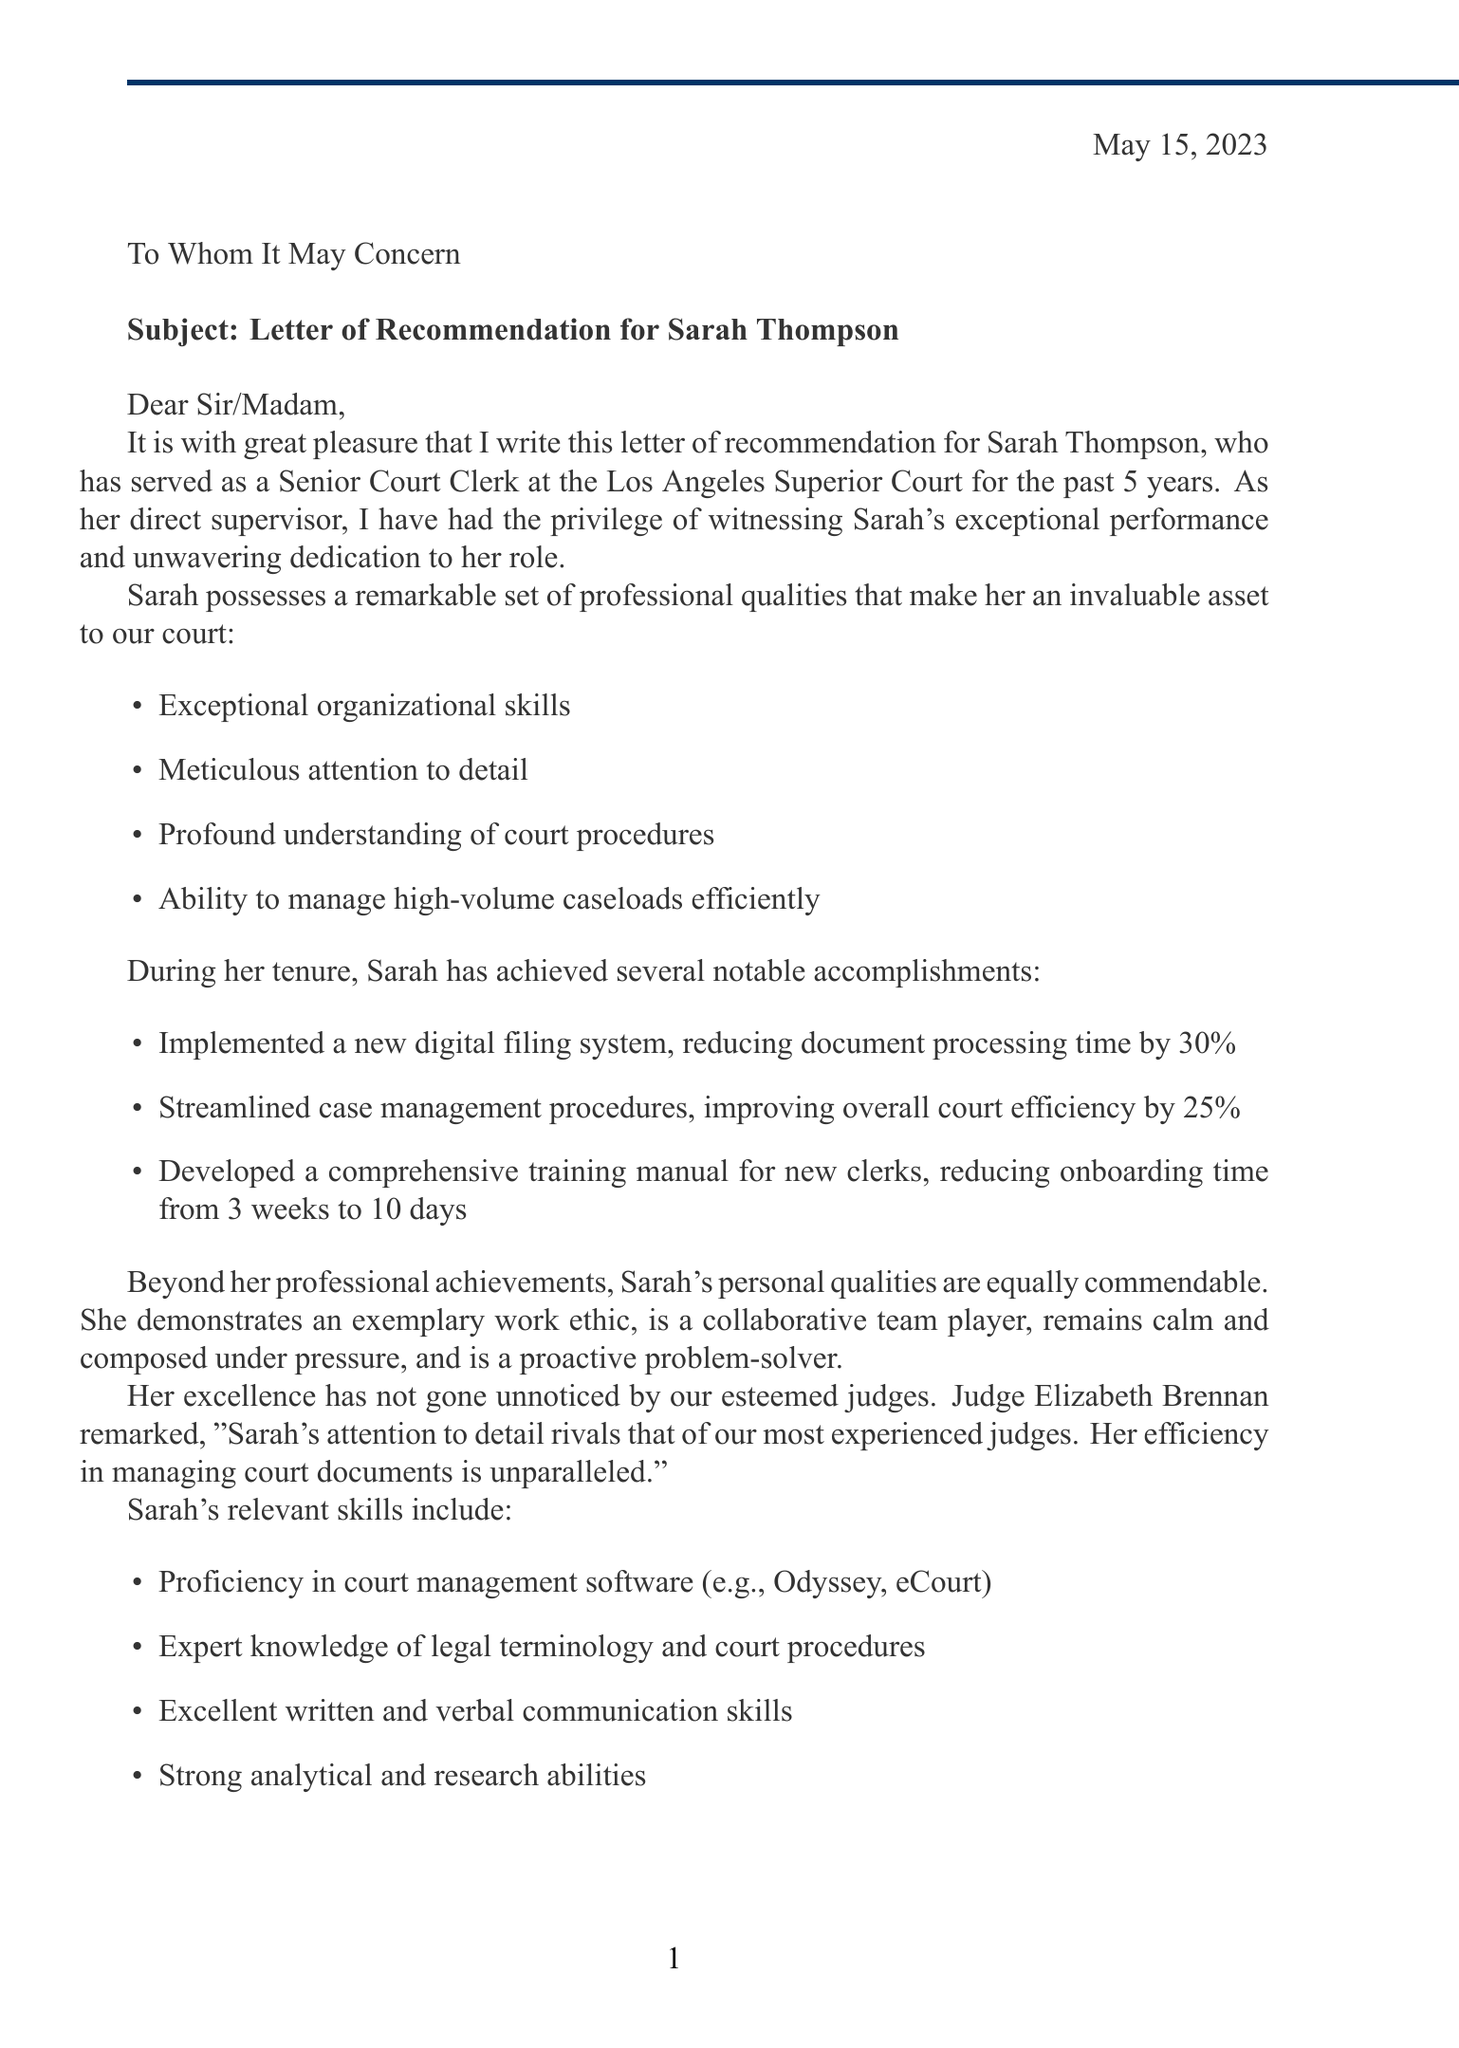What is the date of the letter? The date of the letter is stated at the beginning of the document.
Answer: May 15, 2023 Who is the recipient of the letter? The recipient is addressed in the salutation of the letter.
Answer: To Whom It May Concern What is the position of the person being recommended? The position is mentioned in the introduction of the letter.
Answer: Senior Court Clerk How many years has Sarah Thompson worked at the Los Angeles Superior Court? The duration of Sarah's employment is specified in the introduction.
Answer: 5 years What professional quality highlights Sarah's approach to handling paperwork? The qualities listed under professional qualities include one specifically about attention to detail.
Answer: Meticulous attention to detail What was the impact of the implemented digital filing system? The document mentions a specific outcome related to this system under specific accomplishments.
Answer: Reduced document processing time by 30% Who praised Sarah's attention to detail? The letter includes a quote from a judge commending her work.
Answer: Judge Elizabeth Brennan What percentage did overall court efficiency improve after streamlining case management procedures? This improvement is noted among Sarah's specific accomplishments.
Answer: 25% What is the email contact for further information? The document states contact information in the conclusion section.
Answer: james.wilson@lasc.gov 